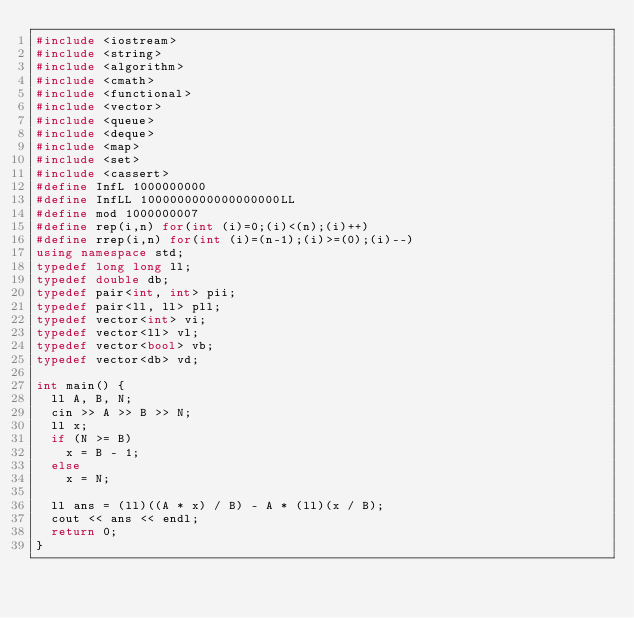<code> <loc_0><loc_0><loc_500><loc_500><_C++_>#include <iostream>
#include <string>
#include <algorithm>
#include <cmath>
#include <functional>
#include <vector>
#include <queue>
#include <deque>
#include <map>
#include <set>
#include <cassert>
#define InfL 1000000000
#define InfLL 1000000000000000000LL
#define mod 1000000007
#define rep(i,n) for(int (i)=0;(i)<(n);(i)++)
#define rrep(i,n) for(int (i)=(n-1);(i)>=(0);(i)--)
using namespace std;
typedef long long ll;
typedef double db;
typedef pair<int, int> pii;
typedef pair<ll, ll> pll;
typedef vector<int> vi;
typedef vector<ll> vl;
typedef vector<bool> vb;
typedef vector<db> vd;

int main() {
	ll A, B, N;
	cin >> A >> B >> N;
	ll x;
	if (N >= B)
		x = B - 1;
	else
		x = N;

	ll ans = (ll)((A * x) / B) - A * (ll)(x / B);
	cout << ans << endl;
	return 0;
}</code> 